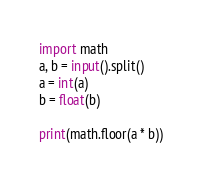Convert code to text. <code><loc_0><loc_0><loc_500><loc_500><_Python_>import math
a, b = input().split()
a = int(a)
b = float(b)

print(math.floor(a * b))</code> 